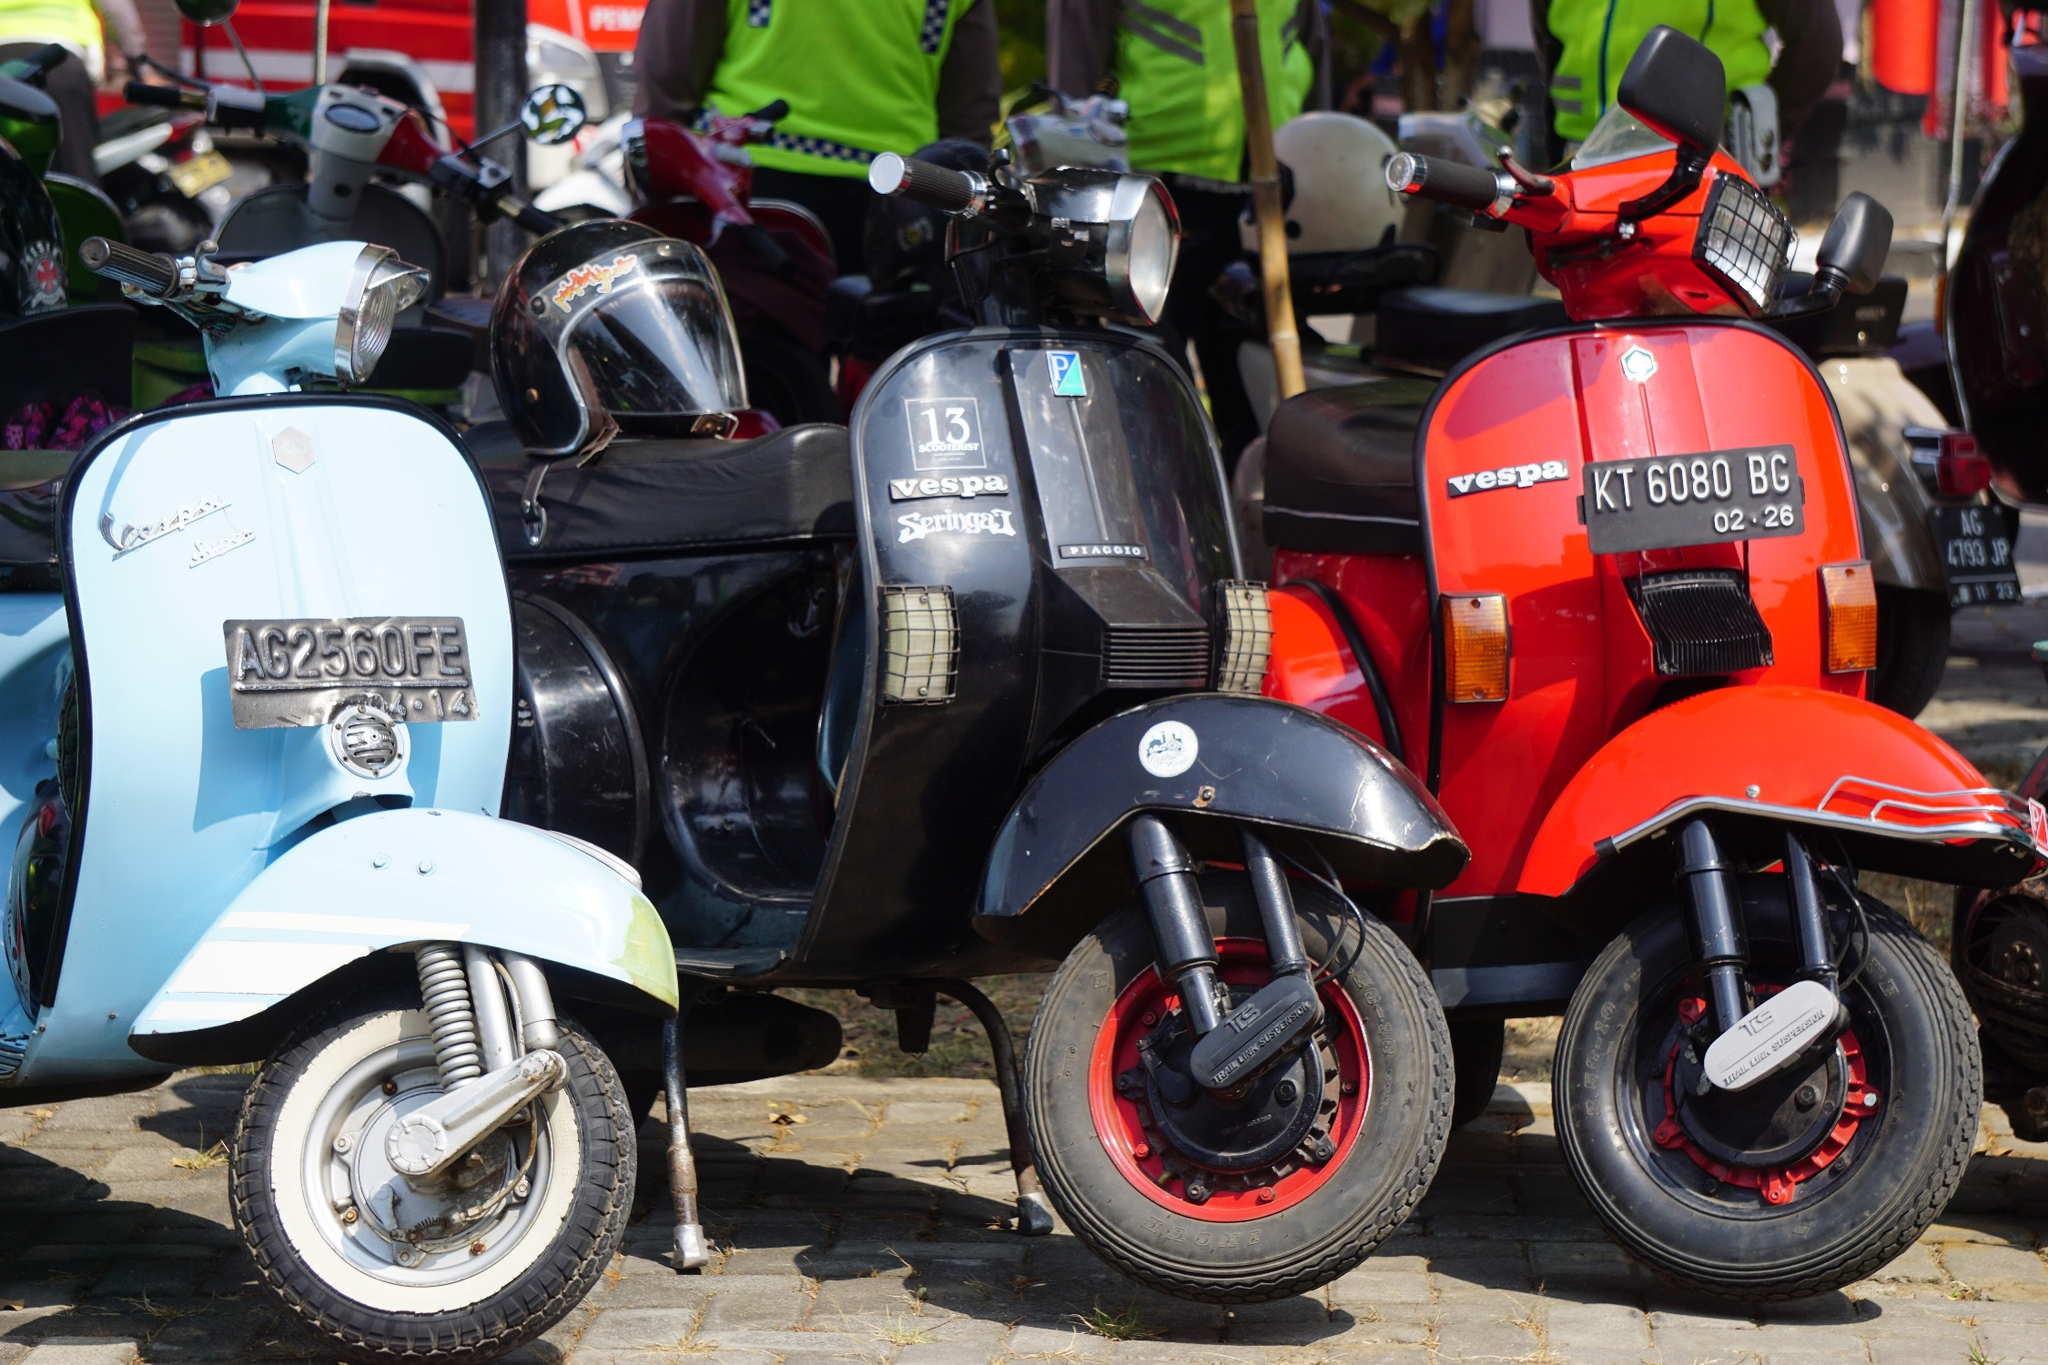What stories could these scooters tell if they could talk? These Vespa scooters could likely share an array of fascinating stories, from scenic journeys through the countryside to daily commutes that witnessed the changing seasons. Each sticker and scratch might tell a story of an adventurous rider who explored winding coastal roads or navigated the bustling city streets. They might recount stories of first dates that took place under starlit skies or the simple joy of cruising down a sunny boulevard. Older scooters might have tales of restoration and the hands that lovingly revived them, while every ride captures the essence of freedom, exploration, and the timeless joy of riding a Vespa. Imagine a creative and whimsical tale involving these scooters. In a whimsical world, these Vespa scooters aren't just modes of transport but are enchanted and brimming with personality. By night, they come to life and embark on magical adventures through the town. One evening, as the moon beams down on the cobblestone street, the blue Vespa named Bella, the black one named Nero, and the fiery red Vespa named Rosso spring to life. Bella dreams of exploring the nearby forest glades, Nero craves the mystery of the old castle ruins, and Rosso seeks the excitement of a secret underground music club. Together, they race through the moonlit paths, startling nocturnal critters and discovering hidden treasures. They encounter playful faeries who guide them, share riddle-solved clues to ancient artifacts, and uncover secret passages unknown to their human riders. By dawn, they return to their original spots, brimming with stories of their nightly escapades, ready to nap under the sun till the next enchanted night. 